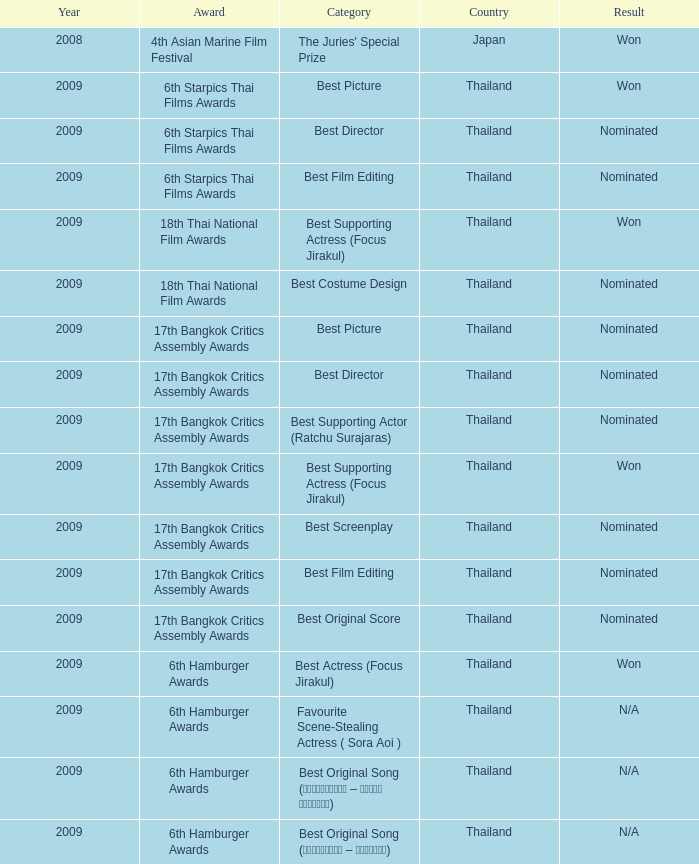At the 17th bangkok critics assembly awards, which country was nominated for the best screenplay award? Thailand. 